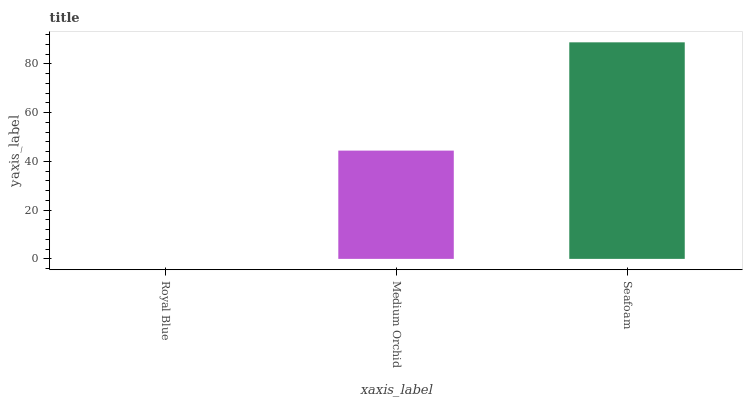Is Royal Blue the minimum?
Answer yes or no. Yes. Is Seafoam the maximum?
Answer yes or no. Yes. Is Medium Orchid the minimum?
Answer yes or no. No. Is Medium Orchid the maximum?
Answer yes or no. No. Is Medium Orchid greater than Royal Blue?
Answer yes or no. Yes. Is Royal Blue less than Medium Orchid?
Answer yes or no. Yes. Is Royal Blue greater than Medium Orchid?
Answer yes or no. No. Is Medium Orchid less than Royal Blue?
Answer yes or no. No. Is Medium Orchid the high median?
Answer yes or no. Yes. Is Medium Orchid the low median?
Answer yes or no. Yes. Is Seafoam the high median?
Answer yes or no. No. Is Seafoam the low median?
Answer yes or no. No. 